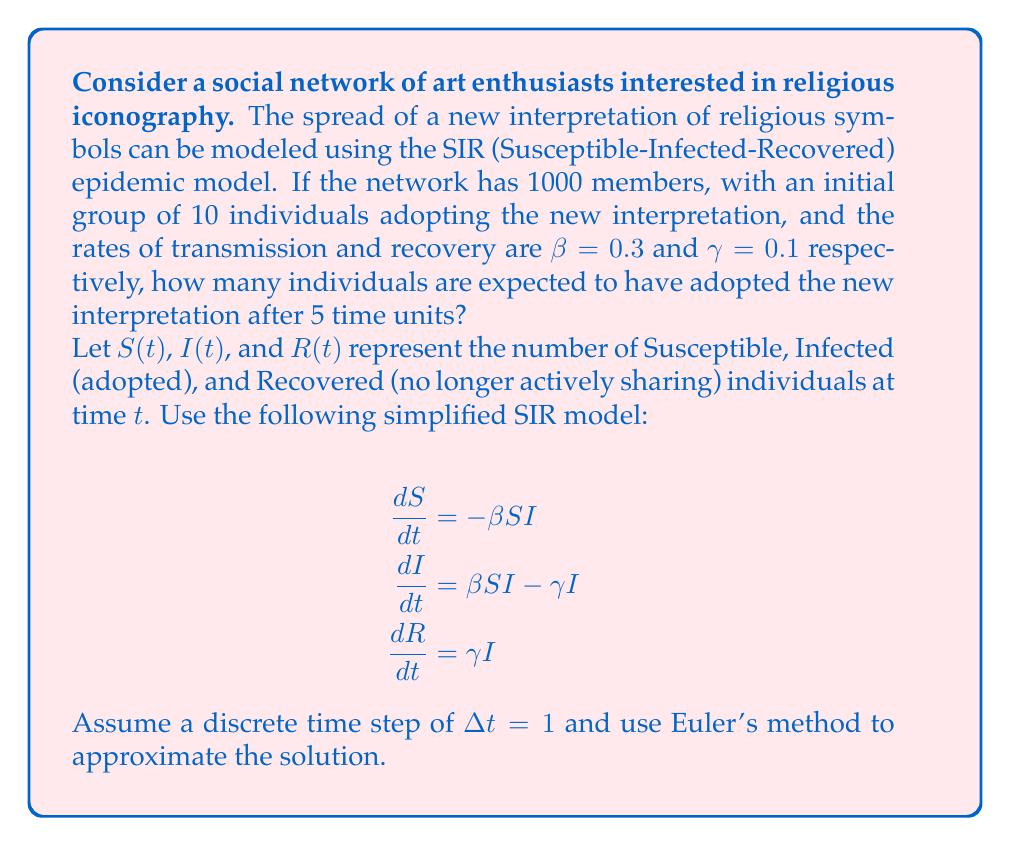Can you solve this math problem? To solve this problem, we'll use Euler's method to approximate the solution of the SIR model over 5 time units. We'll start by setting up our initial conditions and then iterate through each time step.

Initial conditions:
S(0) = 990 (1000 total - 10 initial adopters)
I(0) = 10
R(0) = 0
β = 0.3
γ = 0.1
Δt = 1

Euler's method for each variable:
$$S(t+1) = S(t) + \frac{dS}{dt}\Delta t = S(t) - \beta S(t)I(t)\Delta t$$
$$I(t+1) = I(t) + \frac{dI}{dt}\Delta t = I(t) + (\beta S(t)I(t) - \gamma I(t))\Delta t$$
$$R(t+1) = R(t) + \frac{dR}{dt}\Delta t = R(t) + \gamma I(t)\Delta t$$

Let's calculate for each time step:

t = 0 to t = 1:
S(1) = 990 - 0.3 * 990 * 10 * 1 = 693
I(1) = 10 + (0.3 * 990 * 10 - 0.1 * 10) * 1 = 307
R(1) = 0 + 0.1 * 10 * 1 = 1

t = 1 to t = 2:
S(2) = 693 - 0.3 * 693 * 307 * 1 ≈ 129
I(2) = 307 + (0.3 * 693 * 307 - 0.1 * 307) * 1 ≈ 840
R(2) = 1 + 0.1 * 307 * 1 ≈ 32

t = 2 to t = 3:
S(3) ≈ 129 - 0.3 * 129 * 840 * 1 ≈ 4
I(3) ≈ 840 + (0.3 * 129 * 840 - 0.1 * 840) * 1 ≈ 878
R(3) ≈ 32 + 0.1 * 840 * 1 ≈ 116

t = 3 to t = 4:
S(4) ≈ 4 - 0.3 * 4 * 878 * 1 ≈ 0
I(4) ≈ 878 + (0.3 * 4 * 878 - 0.1 * 878) * 1 ≈ 795
R(4) ≈ 116 + 0.1 * 878 * 1 ≈ 204

t = 4 to t = 5:
S(5) ≈ 0
I(5) ≈ 795 + (0.3 * 0 * 795 - 0.1 * 795) * 1 ≈ 716
R(5) ≈ 204 + 0.1 * 795 * 1 ≈ 284

After 5 time units, the number of individuals who have adopted the new interpretation is the sum of I(5) and R(5), as both groups have encountered the idea.
Answer: After 5 time units, approximately 1000 individuals (716 currently sharing + 284 no longer actively sharing) are expected to have adopted the new interpretation of religious symbols. 